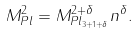<formula> <loc_0><loc_0><loc_500><loc_500>M _ { P l } ^ { 2 } = M _ { P l _ { 3 + 1 + \delta } } ^ { 2 + \delta } n ^ { \delta } .</formula> 